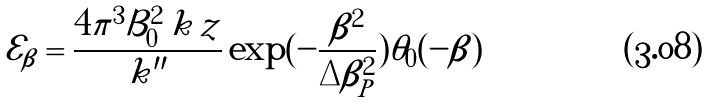Convert formula to latex. <formula><loc_0><loc_0><loc_500><loc_500>\mathcal { E } _ { \beta } = \frac { 4 \pi ^ { 3 } \mathcal { B } _ { 0 } ^ { 2 } \, k \, z } { k ^ { \prime \prime } } \exp ( - \frac { \beta ^ { 2 } } { \Delta \beta _ { P } ^ { 2 } } ) \theta _ { 0 } ( - \beta )</formula> 